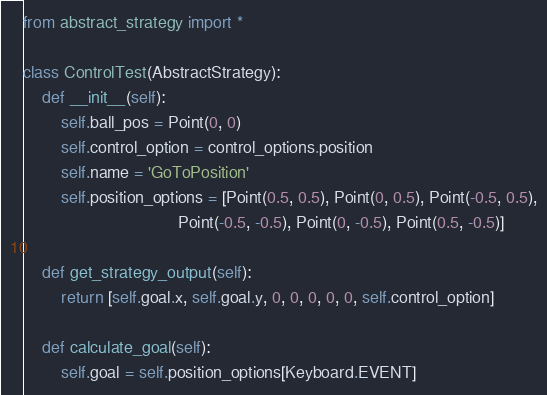Convert code to text. <code><loc_0><loc_0><loc_500><loc_500><_Python_>from abstract_strategy import *

class ControlTest(AbstractStrategy):
    def __init__(self):
        self.ball_pos = Point(0, 0)
        self.control_option = control_options.position
        self.name = 'GoToPosition'
        self.position_options = [Point(0.5, 0.5), Point(0, 0.5), Point(-0.5, 0.5),
                                 Point(-0.5, -0.5), Point(0, -0.5), Point(0.5, -0.5)]

    def get_strategy_output(self):
        return [self.goal.x, self.goal.y, 0, 0, 0, 0, 0, self.control_option]

    def calculate_goal(self):
        self.goal = self.position_options[Keyboard.EVENT]
</code> 